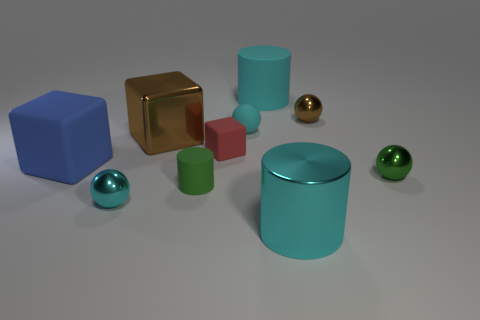There is a big rubber cylinder; is its color the same as the tiny shiny object that is to the left of the red object?
Your response must be concise. Yes. Is there another thing that has the same shape as the red rubber object?
Keep it short and to the point. Yes. There is a cylinder behind the small brown object; is its size the same as the brown object in front of the small brown metal ball?
Make the answer very short. Yes. Are there more cyan balls than metal objects?
Offer a very short reply. No. What number of small brown spheres have the same material as the brown block?
Your answer should be very brief. 1. Is the shape of the small cyan matte object the same as the small brown shiny thing?
Your response must be concise. Yes. What is the size of the cyan sphere that is behind the small metal sphere that is in front of the rubber cylinder that is on the left side of the red thing?
Provide a succinct answer. Small. Is there a brown shiny block that is right of the cyan thing that is on the left side of the large brown block?
Ensure brevity in your answer.  Yes. There is a big shiny object that is behind the large metallic object that is in front of the small rubber cylinder; what number of small cyan spheres are behind it?
Provide a succinct answer. 1. There is a large object that is both in front of the large shiny cube and behind the metal cylinder; what color is it?
Provide a short and direct response. Blue. 